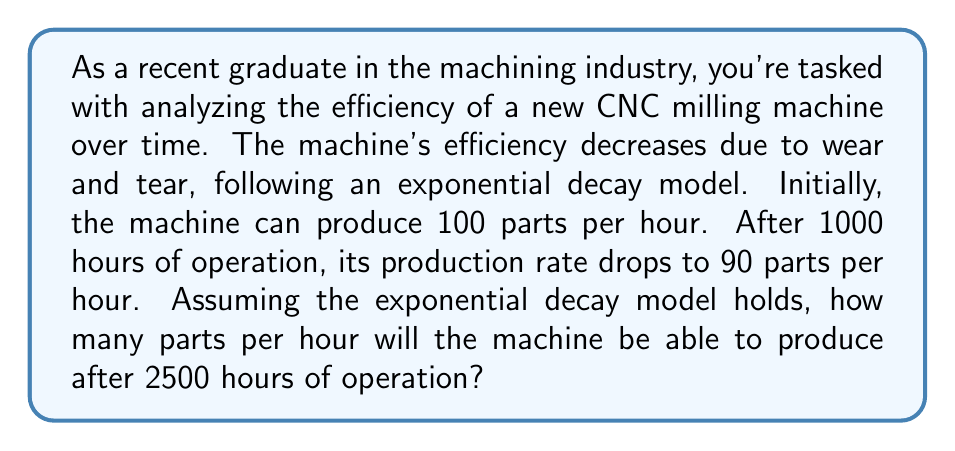Provide a solution to this math problem. Let's approach this step-by-step using the exponential decay model:

1) The general form of exponential decay is:

   $$N(t) = N_0 \cdot e^{-rt}$$

   Where:
   $N(t)$ is the quantity at time $t$
   $N_0$ is the initial quantity
   $r$ is the decay rate
   $t$ is the time

2) We know:
   $N_0 = 100$ parts/hour (initial production rate)
   $N(1000) = 90$ parts/hour (production rate after 1000 hours)
   We need to find $r$ (decay rate)

3) Plugging in what we know:

   $$90 = 100 \cdot e^{-1000r}$$

4) Solving for $r$:

   $$\frac{90}{100} = e^{-1000r}$$
   $$\ln(0.9) = -1000r$$
   $$r = -\frac{\ln(0.9)}{1000} \approx 0.0001054$$

5) Now that we have $r$, we can use the model to predict the production rate after 2500 hours:

   $$N(2500) = 100 \cdot e^{-0.0001054 \cdot 2500}$$

6) Calculating:

   $$N(2500) = 100 \cdot e^{-0.2635} \approx 76.83$$

Therefore, after 2500 hours, the machine will produce approximately 76.83 parts per hour.
Answer: 76.83 parts per hour 